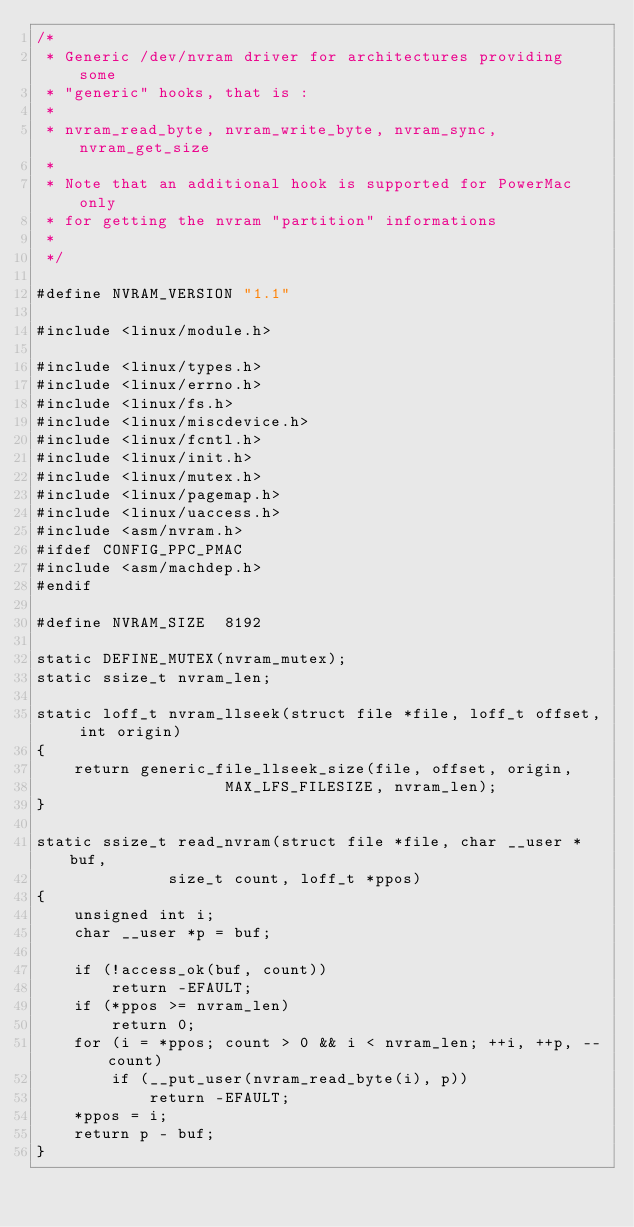Convert code to text. <code><loc_0><loc_0><loc_500><loc_500><_C_>/*
 * Generic /dev/nvram driver for architectures providing some
 * "generic" hooks, that is :
 *
 * nvram_read_byte, nvram_write_byte, nvram_sync, nvram_get_size
 *
 * Note that an additional hook is supported for PowerMac only
 * for getting the nvram "partition" informations
 *
 */

#define NVRAM_VERSION "1.1"

#include <linux/module.h>

#include <linux/types.h>
#include <linux/errno.h>
#include <linux/fs.h>
#include <linux/miscdevice.h>
#include <linux/fcntl.h>
#include <linux/init.h>
#include <linux/mutex.h>
#include <linux/pagemap.h>
#include <linux/uaccess.h>
#include <asm/nvram.h>
#ifdef CONFIG_PPC_PMAC
#include <asm/machdep.h>
#endif

#define NVRAM_SIZE	8192

static DEFINE_MUTEX(nvram_mutex);
static ssize_t nvram_len;

static loff_t nvram_llseek(struct file *file, loff_t offset, int origin)
{
	return generic_file_llseek_size(file, offset, origin,
					MAX_LFS_FILESIZE, nvram_len);
}

static ssize_t read_nvram(struct file *file, char __user *buf,
			  size_t count, loff_t *ppos)
{
	unsigned int i;
	char __user *p = buf;

	if (!access_ok(buf, count))
		return -EFAULT;
	if (*ppos >= nvram_len)
		return 0;
	for (i = *ppos; count > 0 && i < nvram_len; ++i, ++p, --count)
		if (__put_user(nvram_read_byte(i), p))
			return -EFAULT;
	*ppos = i;
	return p - buf;
}
</code> 